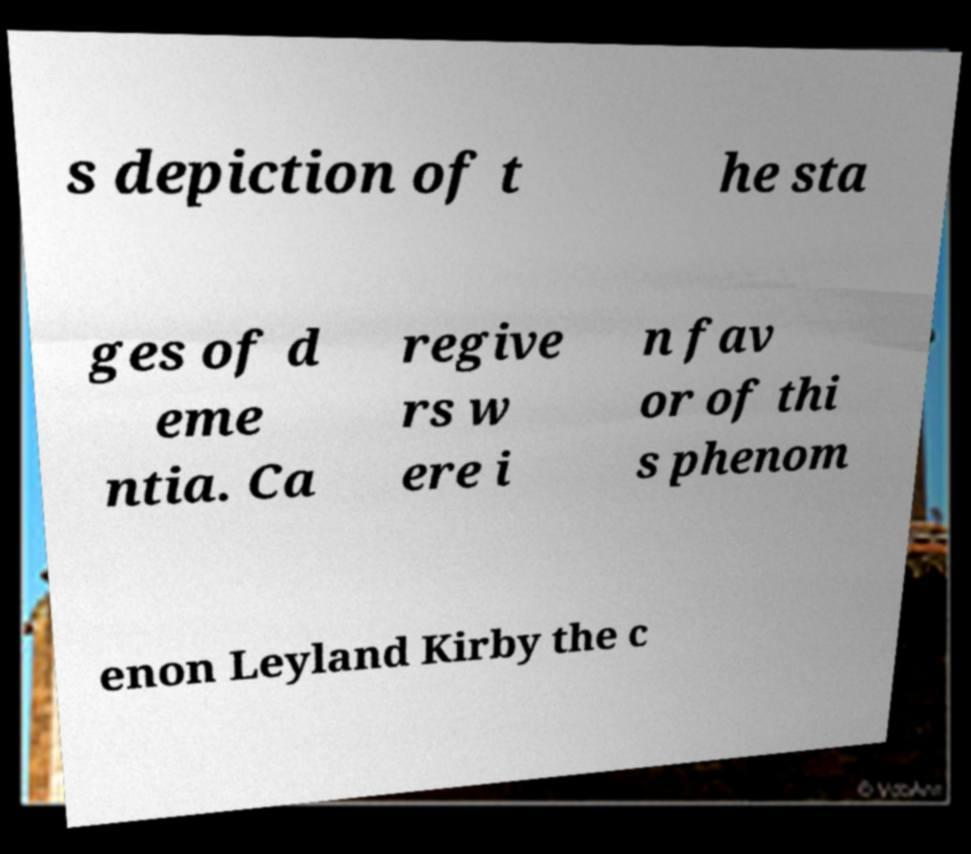Can you accurately transcribe the text from the provided image for me? s depiction of t he sta ges of d eme ntia. Ca regive rs w ere i n fav or of thi s phenom enon Leyland Kirby the c 